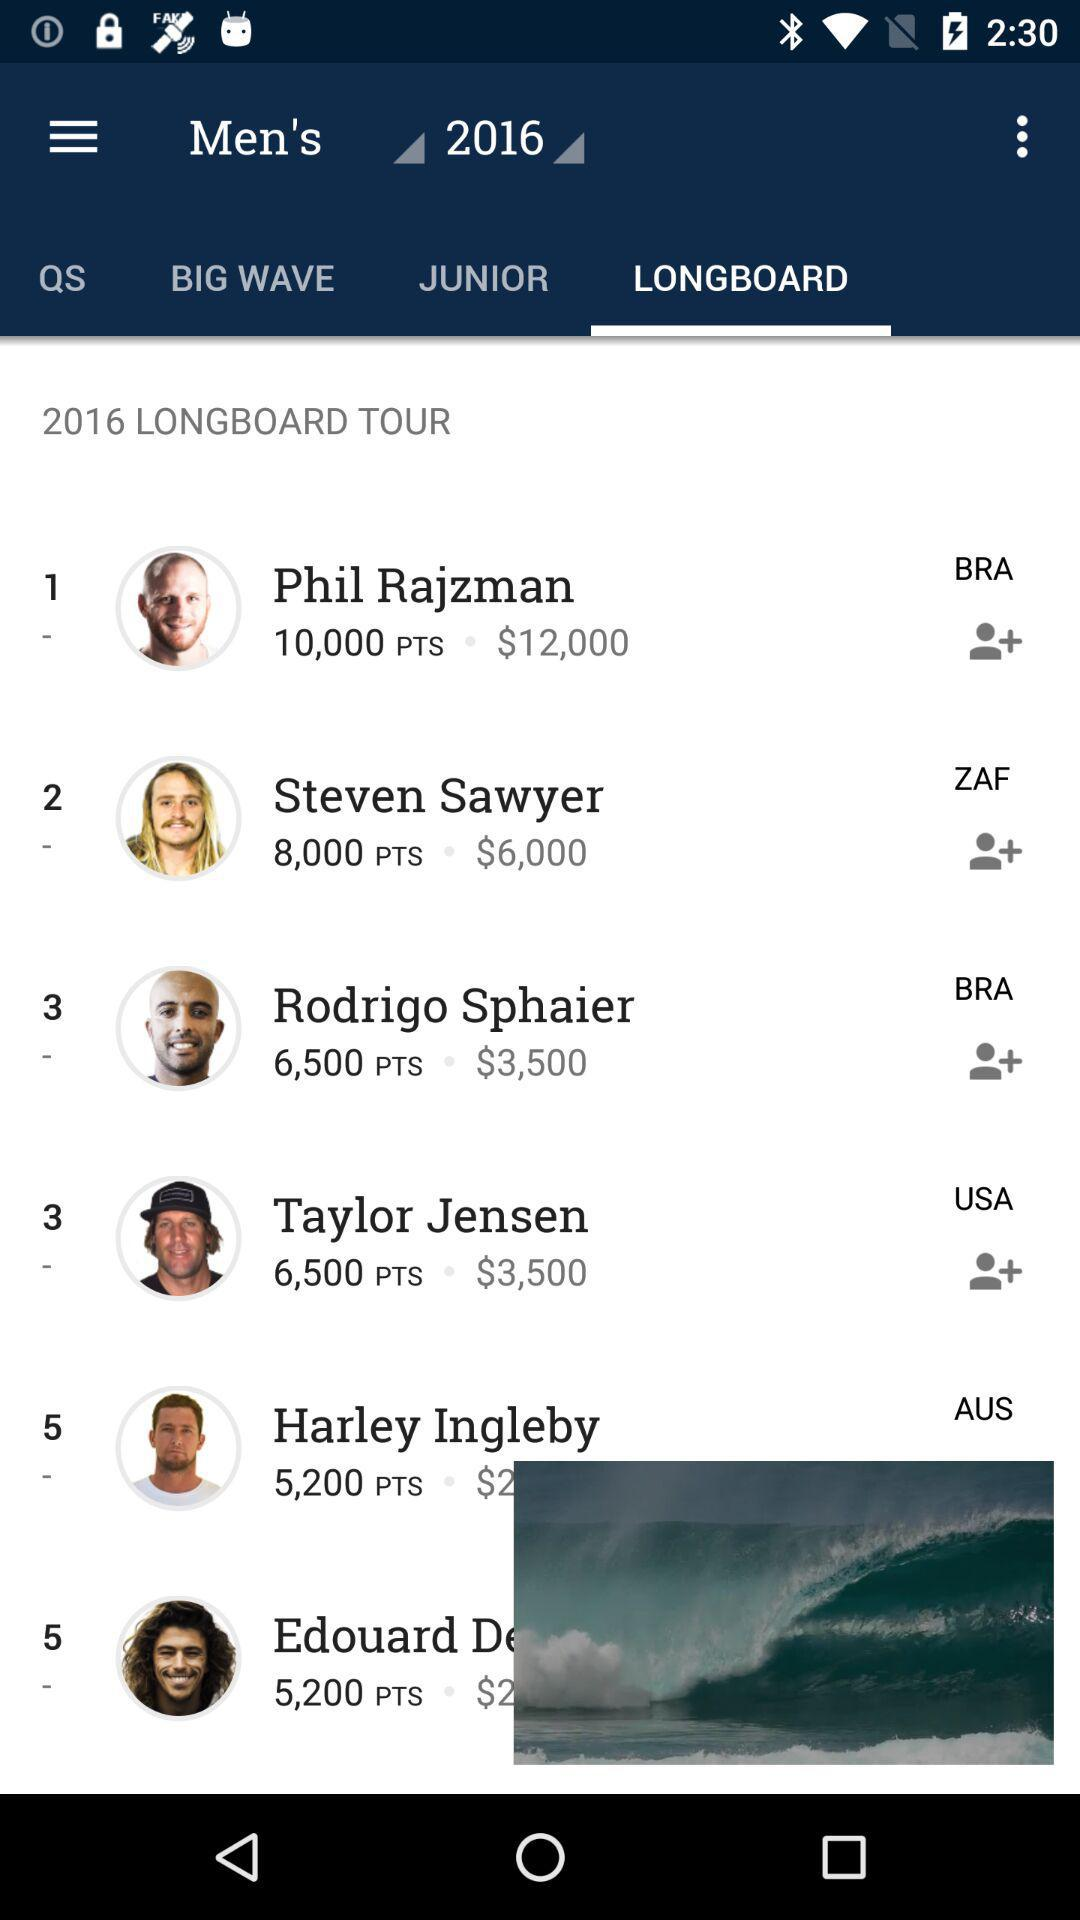How many points does Phil Rajzman have? Phil Rajzman has 10,000 points. 